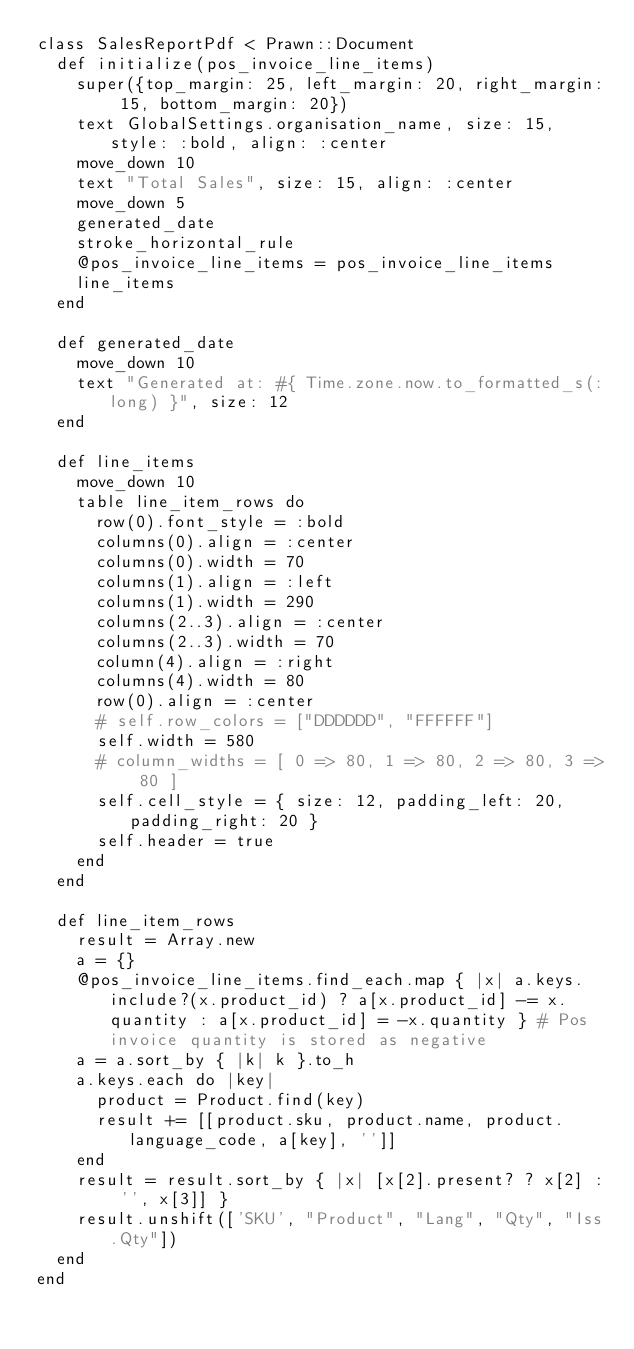<code> <loc_0><loc_0><loc_500><loc_500><_Ruby_>class SalesReportPdf < Prawn::Document
  def initialize(pos_invoice_line_items)
    super({top_margin: 25, left_margin: 20, right_margin: 15, bottom_margin: 20})
    text GlobalSettings.organisation_name, size: 15, style: :bold, align: :center
    move_down 10
    text "Total Sales", size: 15, align: :center
    move_down 5
    generated_date
    stroke_horizontal_rule
    @pos_invoice_line_items = pos_invoice_line_items
    line_items
  end

  def generated_date
    move_down 10
    text "Generated at: #{ Time.zone.now.to_formatted_s(:long) }", size: 12
  end

  def line_items
    move_down 10
    table line_item_rows do
      row(0).font_style = :bold
      columns(0).align = :center
      columns(0).width = 70
      columns(1).align = :left
      columns(1).width = 290
      columns(2..3).align = :center
      columns(2..3).width = 70
      column(4).align = :right
      columns(4).width = 80
      row(0).align = :center
      # self.row_colors = ["DDDDDD", "FFFFFF"]
      self.width = 580
      # column_widths = [ 0 => 80, 1 => 80, 2 => 80, 3 => 80 ]
      self.cell_style = { size: 12, padding_left: 20, padding_right: 20 }
      self.header = true
    end
  end

  def line_item_rows
    result = Array.new
    a = {}
    @pos_invoice_line_items.find_each.map { |x| a.keys.include?(x.product_id) ? a[x.product_id] -= x.quantity : a[x.product_id] = -x.quantity } # Pos invoice quantity is stored as negative
    a = a.sort_by { |k| k }.to_h
    a.keys.each do |key|
      product = Product.find(key)
      result += [[product.sku, product.name, product.language_code, a[key], '']]
    end
    result = result.sort_by { |x| [x[2].present? ? x[2] : '', x[3]] }
    result.unshift(['SKU', "Product", "Lang", "Qty", "Iss.Qty"])
  end
end
</code> 